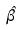Convert formula to latex. <formula><loc_0><loc_0><loc_500><loc_500>\hat { \beta }</formula> 